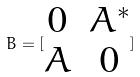<formula> <loc_0><loc_0><loc_500><loc_500>B = [ \begin{matrix} 0 & A ^ { * } \\ A & 0 \end{matrix} ]</formula> 